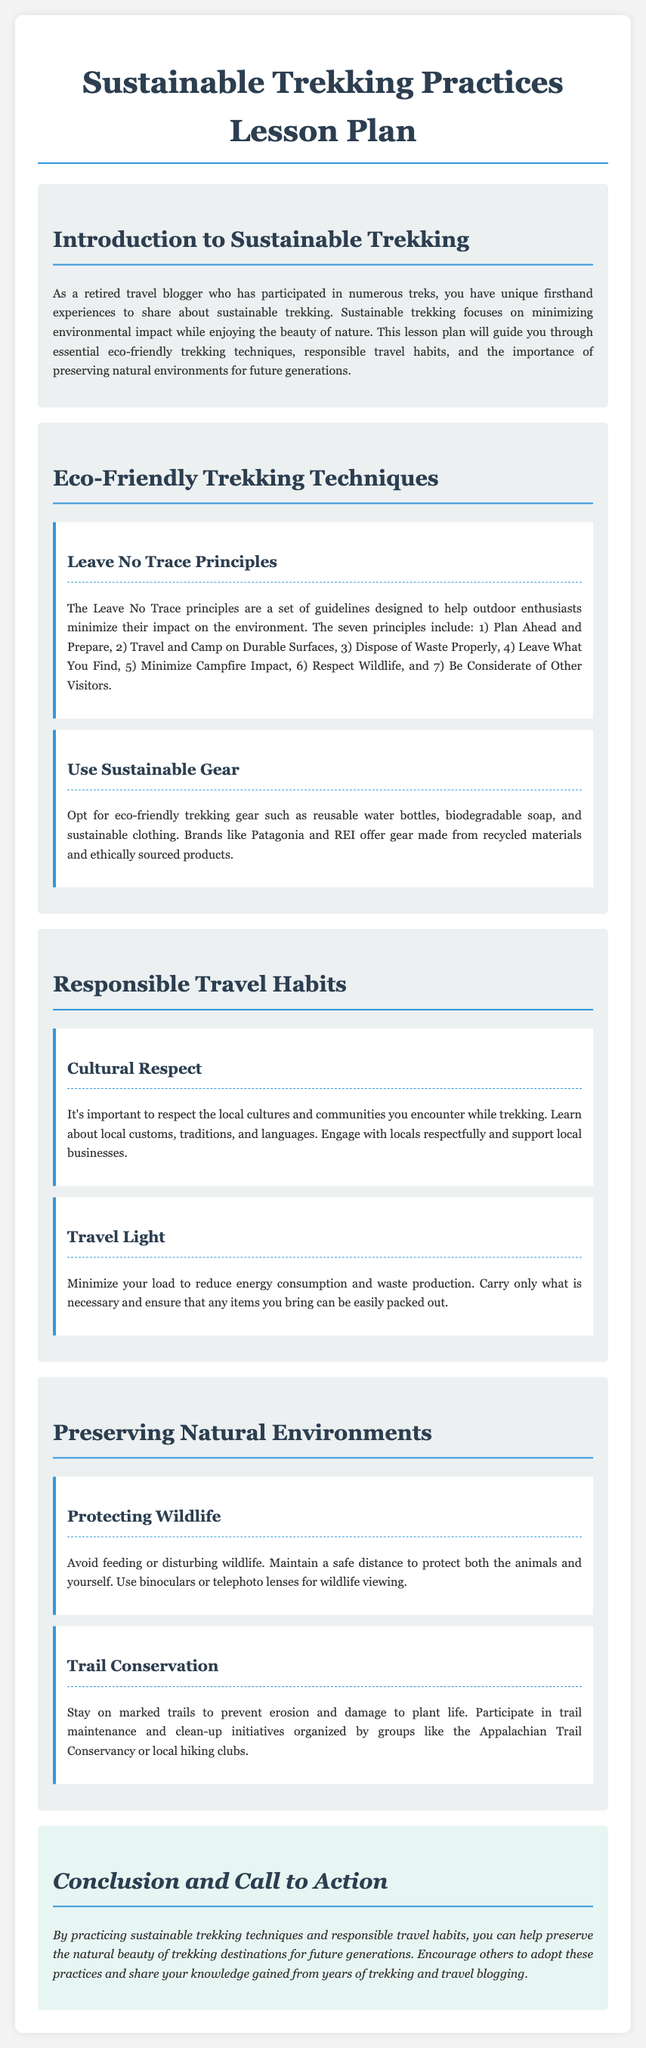What are the Leave No Trace principles? The Leave No Trace principles include guidelines to help outdoor enthusiasts minimize their environmental impact. They are: 1) Plan Ahead and Prepare, 2) Travel and Camp on Durable Surfaces, 3) Dispose of Waste Properly, 4) Leave What You Find, 5) Minimize Campfire Impact, 6) Respect Wildlife, and 7) Be Considerate of Other Visitors.
Answer: Seven principles What should eco-friendly trekking gear include? The document states that eco-friendly trekking gear should include reusable water bottles, biodegradable soap, and sustainable clothing.
Answer: Reusable water bottles, biodegradable soap, and sustainable clothing What is the focus of sustainable trekking? Sustainable trekking focuses on minimizing environmental impact while enjoying the beauty of nature.
Answer: Minimizing environmental impact What cultural practice should trekkers engage in? Trekkers should engage with locals respectfully and support local businesses.
Answer: Respectfully engaging with locals What is one way to protect wildlife while trekking? The document advises to avoid feeding or disturbing wildlife and maintain a safe distance for protection.
Answer: Maintain a safe distance Which trekking organization is mentioned for trail maintenance? The organization mentioned in the document for trail maintenance is the Appalachian Trail Conservancy.
Answer: Appalachian Trail Conservancy How can one minimize their load while trekking? The document suggests that you should carry only what is necessary and ensure that items can be easily packed out.
Answer: Carry only what is necessary What is the conclusion's call to action regarding sustainable trekking? The conclusion encourages individuals to practice sustainable trekking techniques and share knowledge gained from trekking experiences.
Answer: Share knowledge gained from trekking experiences 